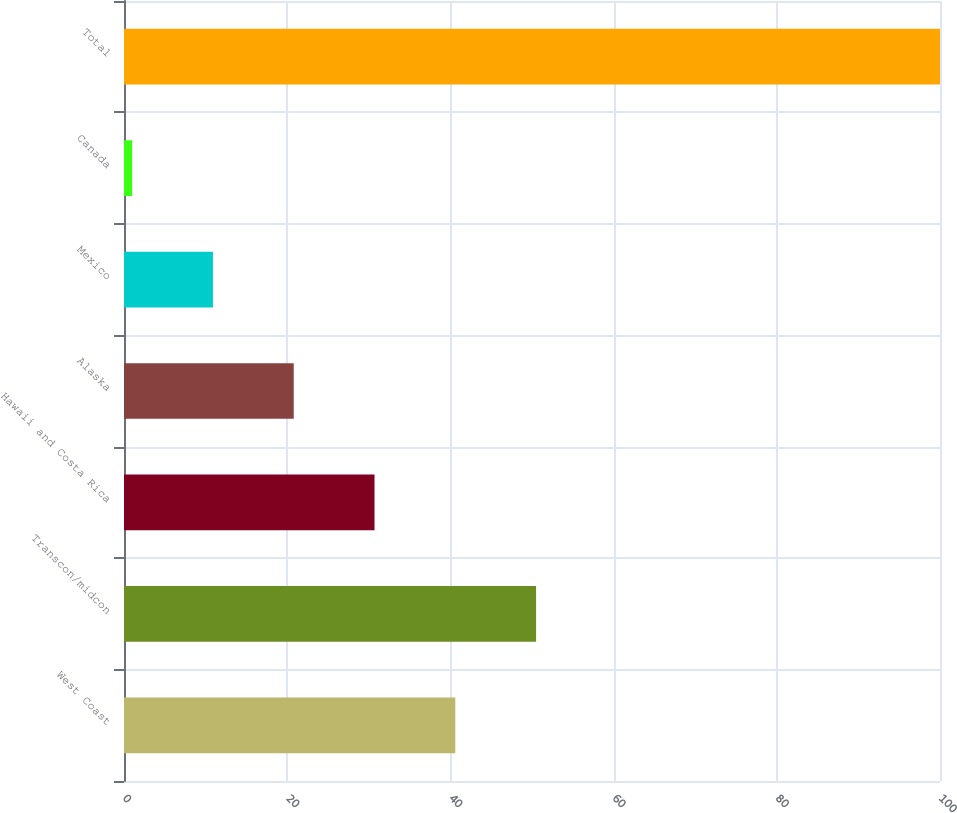Convert chart. <chart><loc_0><loc_0><loc_500><loc_500><bar_chart><fcel>West Coast<fcel>Transcon/midcon<fcel>Hawaii and Costa Rica<fcel>Alaska<fcel>Mexico<fcel>Canada<fcel>Total<nl><fcel>40.6<fcel>50.5<fcel>30.7<fcel>20.8<fcel>10.9<fcel>1<fcel>100<nl></chart> 